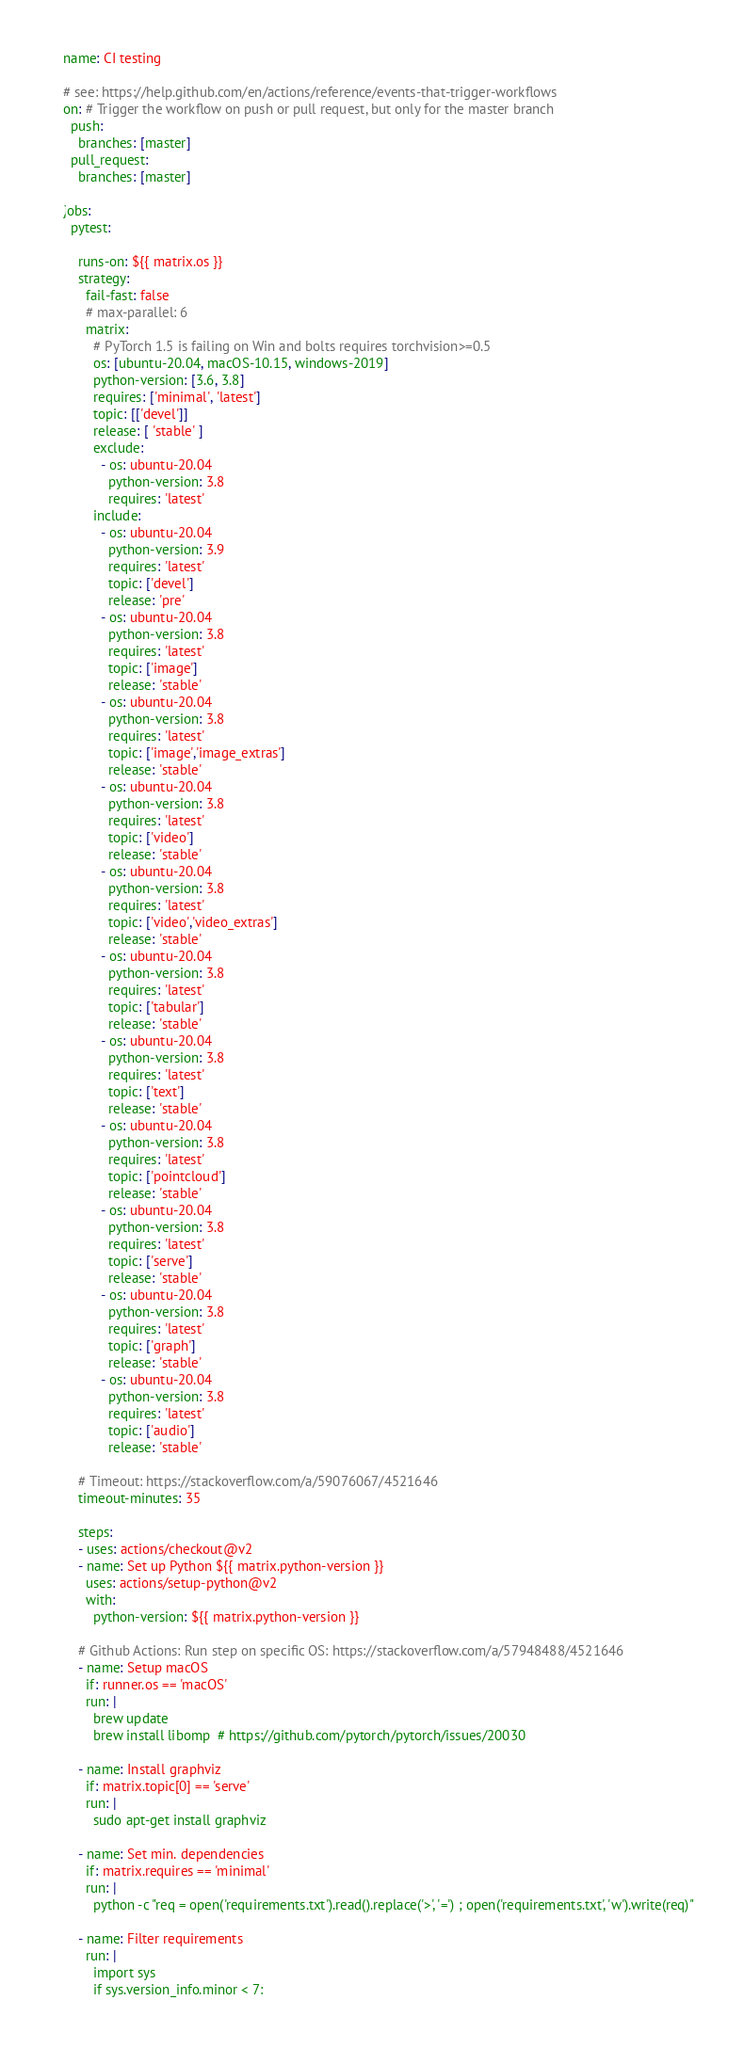Convert code to text. <code><loc_0><loc_0><loc_500><loc_500><_YAML_>name: CI testing

# see: https://help.github.com/en/actions/reference/events-that-trigger-workflows
on: # Trigger the workflow on push or pull request, but only for the master branch
  push:
    branches: [master]
  pull_request:
    branches: [master]

jobs:
  pytest:

    runs-on: ${{ matrix.os }}
    strategy:
      fail-fast: false
      # max-parallel: 6
      matrix:
        # PyTorch 1.5 is failing on Win and bolts requires torchvision>=0.5
        os: [ubuntu-20.04, macOS-10.15, windows-2019]
        python-version: [3.6, 3.8]
        requires: ['minimal', 'latest']
        topic: [['devel']]
        release: [ 'stable' ]
        exclude:
          - os: ubuntu-20.04
            python-version: 3.8
            requires: 'latest'
        include:
          - os: ubuntu-20.04
            python-version: 3.9
            requires: 'latest'
            topic: ['devel']
            release: 'pre'
          - os: ubuntu-20.04
            python-version: 3.8
            requires: 'latest'
            topic: ['image']
            release: 'stable'
          - os: ubuntu-20.04
            python-version: 3.8
            requires: 'latest'
            topic: ['image','image_extras']
            release: 'stable'
          - os: ubuntu-20.04
            python-version: 3.8
            requires: 'latest'
            topic: ['video']
            release: 'stable'
          - os: ubuntu-20.04
            python-version: 3.8
            requires: 'latest'
            topic: ['video','video_extras']
            release: 'stable'
          - os: ubuntu-20.04
            python-version: 3.8
            requires: 'latest'
            topic: ['tabular']
            release: 'stable'
          - os: ubuntu-20.04
            python-version: 3.8
            requires: 'latest'
            topic: ['text']
            release: 'stable'
          - os: ubuntu-20.04
            python-version: 3.8
            requires: 'latest'
            topic: ['pointcloud']
            release: 'stable'
          - os: ubuntu-20.04
            python-version: 3.8
            requires: 'latest'
            topic: ['serve']
            release: 'stable'
          - os: ubuntu-20.04
            python-version: 3.8
            requires: 'latest'
            topic: ['graph']
            release: 'stable'
          - os: ubuntu-20.04
            python-version: 3.8
            requires: 'latest'
            topic: ['audio']
            release: 'stable'

    # Timeout: https://stackoverflow.com/a/59076067/4521646
    timeout-minutes: 35

    steps:
    - uses: actions/checkout@v2
    - name: Set up Python ${{ matrix.python-version }}
      uses: actions/setup-python@v2
      with:
        python-version: ${{ matrix.python-version }}

    # Github Actions: Run step on specific OS: https://stackoverflow.com/a/57948488/4521646
    - name: Setup macOS
      if: runner.os == 'macOS'
      run: |
        brew update
        brew install libomp  # https://github.com/pytorch/pytorch/issues/20030

    - name: Install graphviz
      if: matrix.topic[0] == 'serve'
      run: |
        sudo apt-get install graphviz

    - name: Set min. dependencies
      if: matrix.requires == 'minimal'
      run: |
        python -c "req = open('requirements.txt').read().replace('>', '=') ; open('requirements.txt', 'w').write(req)"

    - name: Filter requirements
      run: |
        import sys
        if sys.version_info.minor < 7:</code> 